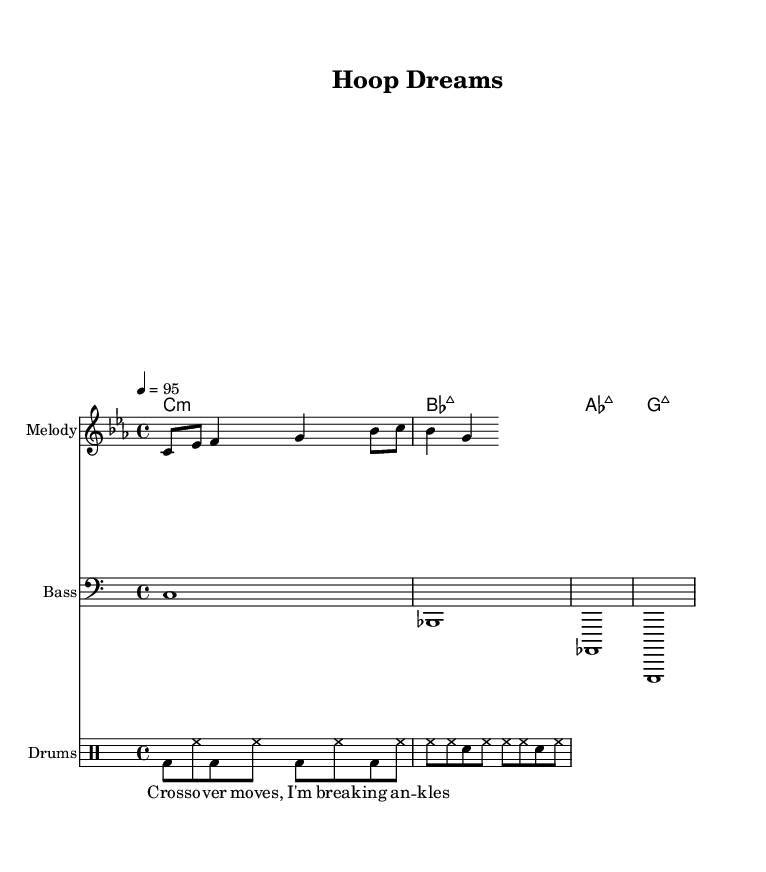What is the key signature of this music? The key signature indicated at the beginning shows C minor, which has three flats (B♭, E♭, A♭).
Answer: C minor What is the time signature of the piece? The time signature displayed at the beginning is 4/4, which means there are four beats in a measure and the quarter note gets one beat.
Answer: 4/4 What is the tempo marking in the sheet music? The tempo marking shows 4♩=95, indicating that the quarter note should be played at a speed of 95 beats per minute.
Answer: 95 What type of chords are used in the harmony section? The harmony section contains chords such as minor and major, specifically C minor, B♭ major, A♭ major, and G major.
Answer: Minor and major How does the lyric reflect a basketball concept? The lyric "Cross-over moves, I'm breaking ankles" uses a basketball metaphor referring to a player executing a crossover dribble to outmaneuver an opponent, thus "breaking their ankles."
Answer: Basketball metaphor What is the primary rhythmic feature of the drum pattern? The drum pattern mainly alternates between bass drum and hi-hat, creating a driving rhythm typical of hip-hop music, with snare accents.
Answer: Bass and hi-hat How many measures are there in the melody? By counting the notes and looking at the structure, there are four measures in the melody corresponding to the 4/4 time signature.
Answer: Four measures 